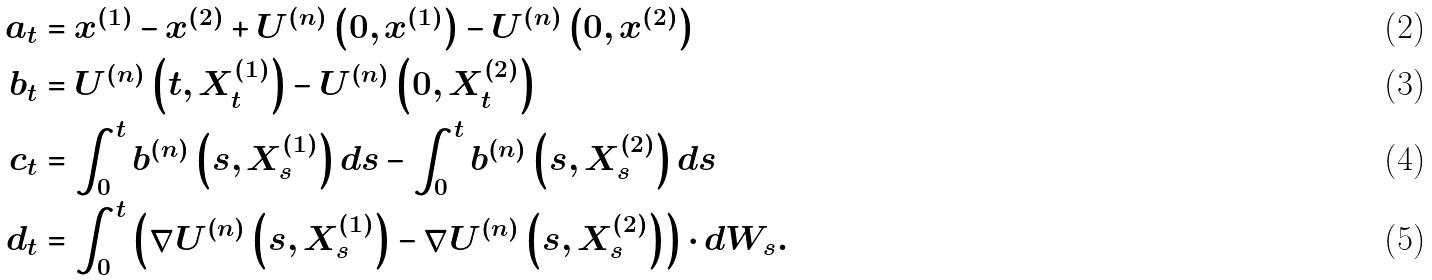<formula> <loc_0><loc_0><loc_500><loc_500>a _ { t } & = x ^ { \left ( 1 \right ) } - x ^ { \left ( 2 \right ) } + U ^ { \left ( n \right ) } \left ( 0 , x ^ { \left ( 1 \right ) } \right ) - U ^ { \left ( n \right ) } \left ( 0 , x ^ { \left ( 2 \right ) } \right ) \\ b _ { t } & = U ^ { \left ( n \right ) } \left ( t , X _ { t } ^ { \left ( 1 \right ) } \right ) - U ^ { \left ( n \right ) } \left ( 0 , X _ { t } ^ { \left ( 2 \right ) } \right ) \\ c _ { t } & = \int _ { 0 } ^ { t } b ^ { \left ( n \right ) } \left ( s , X _ { s } ^ { \left ( 1 \right ) } \right ) d s - \int _ { 0 } ^ { t } b ^ { \left ( n \right ) } \left ( s , X _ { s } ^ { \left ( 2 \right ) } \right ) d s \\ d _ { t } & = \int _ { 0 } ^ { t } \left ( \nabla U ^ { \left ( n \right ) } \left ( s , X _ { s } ^ { \left ( 1 \right ) } \right ) - \nabla U ^ { \left ( n \right ) } \left ( s , X _ { s } ^ { \left ( 2 \right ) } \right ) \right ) \cdot d W _ { s } .</formula> 